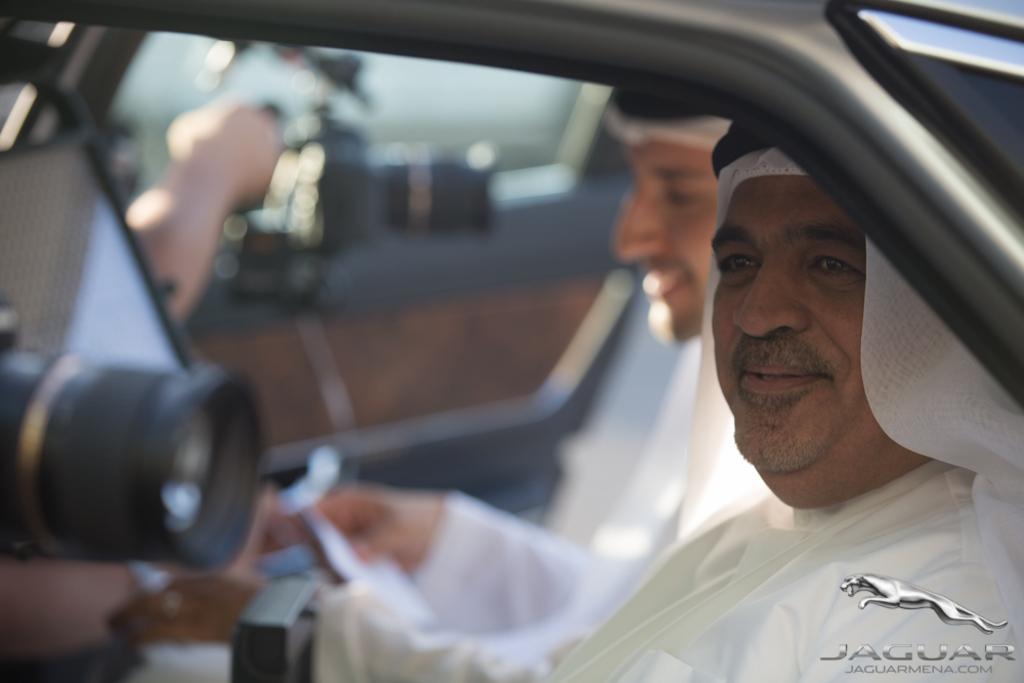In one or two sentences, can you explain what this image depicts? In this picture we can see two persons and here is a camera and in the background we can see reflection of this and it is blurry. 